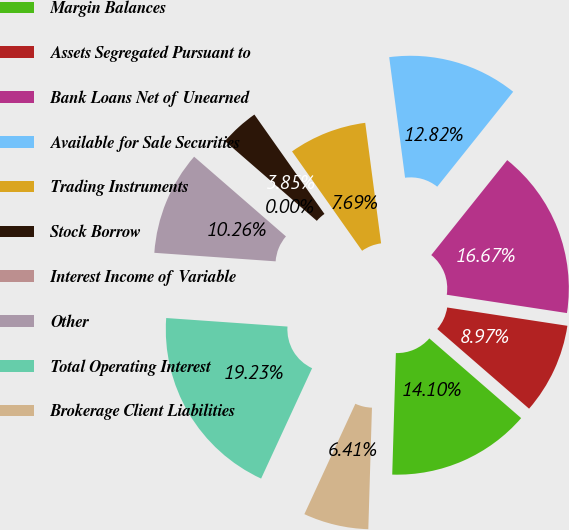Convert chart to OTSL. <chart><loc_0><loc_0><loc_500><loc_500><pie_chart><fcel>Margin Balances<fcel>Assets Segregated Pursuant to<fcel>Bank Loans Net of Unearned<fcel>Available for Sale Securities<fcel>Trading Instruments<fcel>Stock Borrow<fcel>Interest Income of Variable<fcel>Other<fcel>Total Operating Interest<fcel>Brokerage Client Liabilities<nl><fcel>14.1%<fcel>8.97%<fcel>16.67%<fcel>12.82%<fcel>7.69%<fcel>3.85%<fcel>0.0%<fcel>10.26%<fcel>19.23%<fcel>6.41%<nl></chart> 